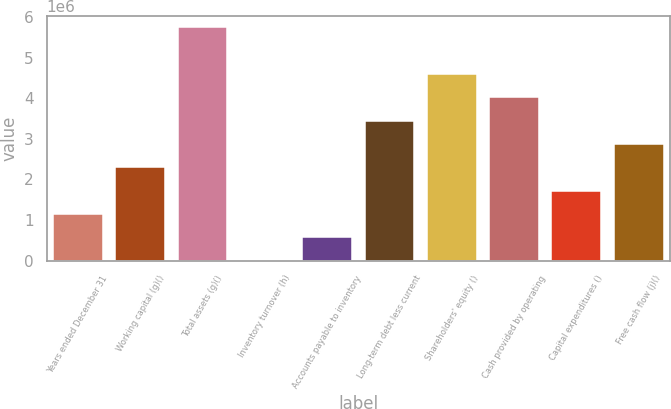<chart> <loc_0><loc_0><loc_500><loc_500><bar_chart><fcel>Years ended December 31<fcel>Working capital (g)()<fcel>Total assets (g)()<fcel>Inventory turnover (h)<fcel>Accounts payable to inventory<fcel>Long-term debt less current<fcel>Shareholders' equity ()<fcel>Cash provided by operating<fcel>Capital expenditures ()<fcel>Free cash flow (j)()<nl><fcel>1.14825e+06<fcel>2.2965e+06<fcel>5.74124e+06<fcel>1.4<fcel>574125<fcel>3.44475e+06<fcel>4.59299e+06<fcel>4.01887e+06<fcel>1.72237e+06<fcel>2.87062e+06<nl></chart> 